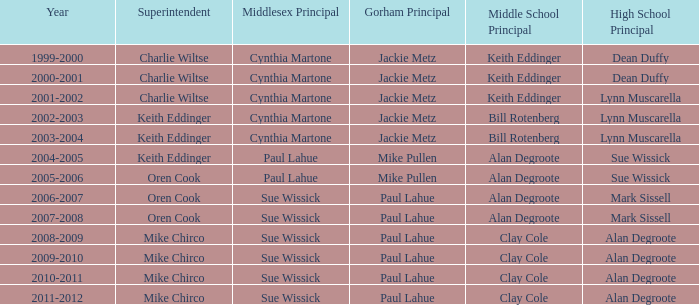How many middlesex principals were there in 2000-2001? 1.0. 